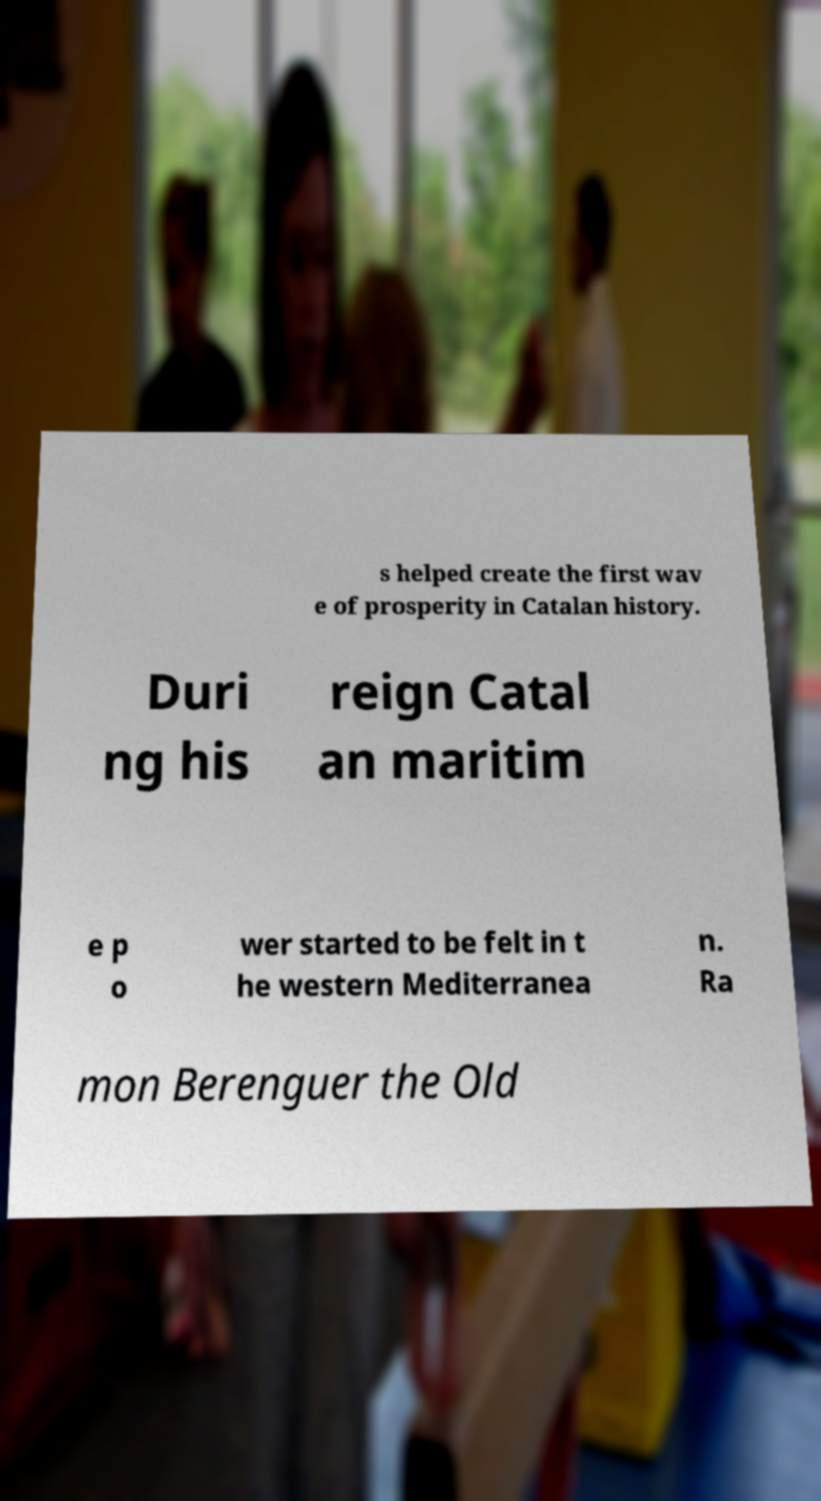Please read and relay the text visible in this image. What does it say? s helped create the first wav e of prosperity in Catalan history. Duri ng his reign Catal an maritim e p o wer started to be felt in t he western Mediterranea n. Ra mon Berenguer the Old 